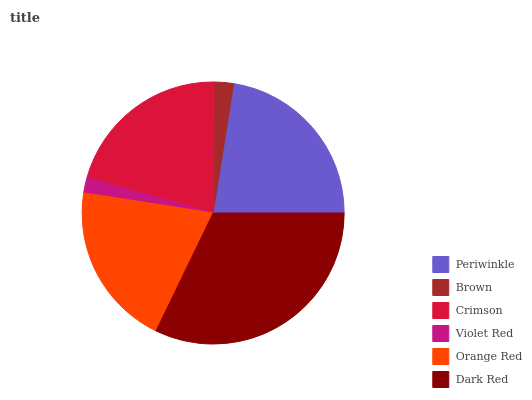Is Violet Red the minimum?
Answer yes or no. Yes. Is Dark Red the maximum?
Answer yes or no. Yes. Is Brown the minimum?
Answer yes or no. No. Is Brown the maximum?
Answer yes or no. No. Is Periwinkle greater than Brown?
Answer yes or no. Yes. Is Brown less than Periwinkle?
Answer yes or no. Yes. Is Brown greater than Periwinkle?
Answer yes or no. No. Is Periwinkle less than Brown?
Answer yes or no. No. Is Crimson the high median?
Answer yes or no. Yes. Is Orange Red the low median?
Answer yes or no. Yes. Is Violet Red the high median?
Answer yes or no. No. Is Periwinkle the low median?
Answer yes or no. No. 